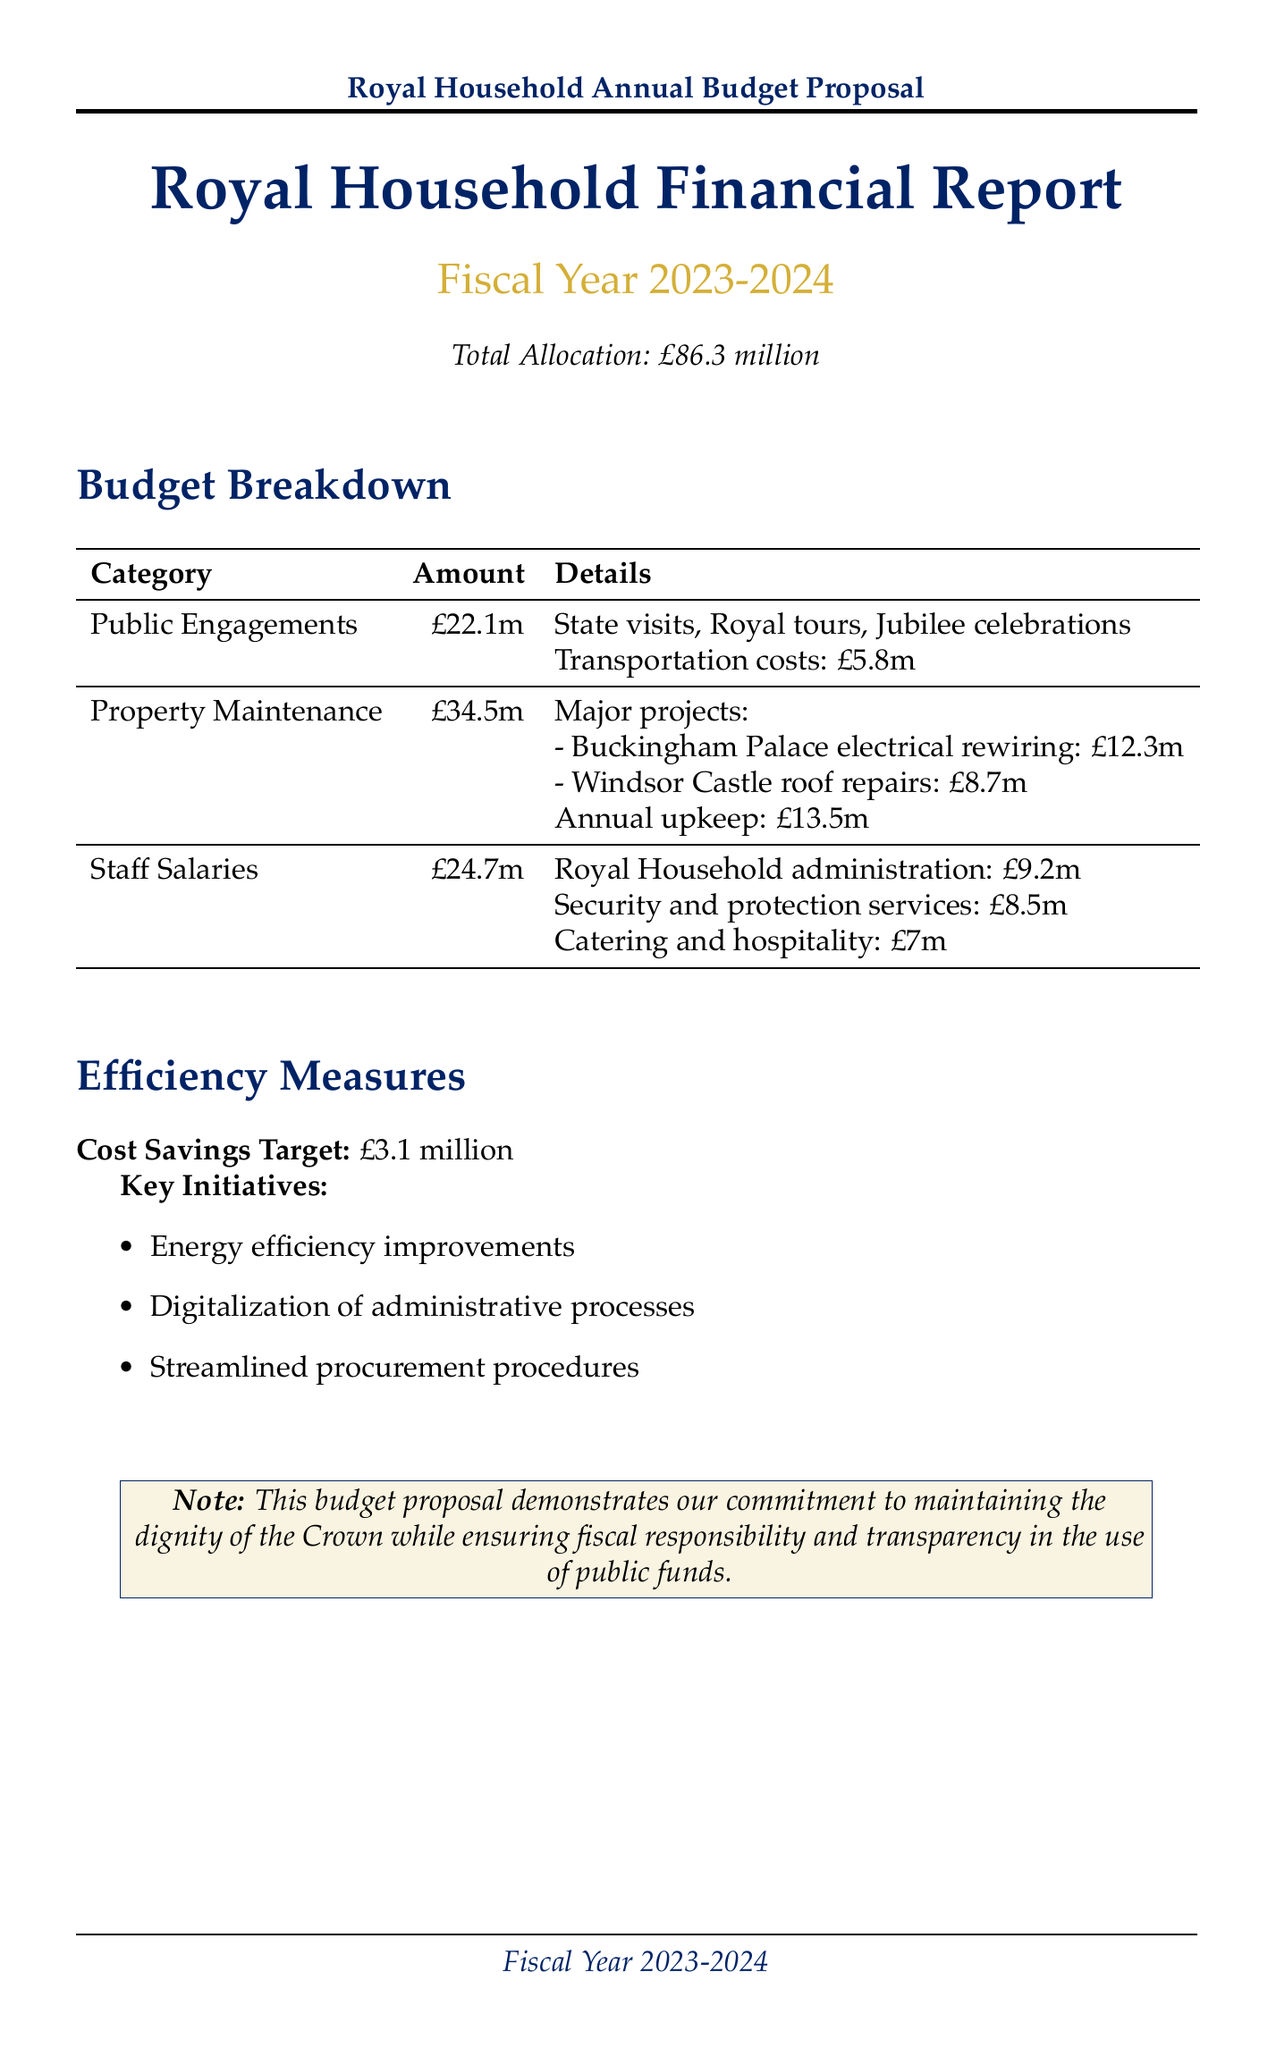What is the total allocation for the fiscal year? The total allocation for the fiscal year is clearly stated in the document.
Answer: £86.3 million How much is allocated for public engagements? The public engagements section specifies the total allocation amount.
Answer: £22.1 million What are the major projects included in property maintenance? The document lists two major projects under property maintenance with their corresponding costs.
Answer: Buckingham Palace electrical rewiring, Windsor Castle roof repairs What is the total allocation for staff salaries? The staff salaries section provides the total allocation amount for that category.
Answer: £24.7 million What is the cost savings target for the efficiency measures? The document mentions a specific cost savings target under efficiency measures.
Answer: £3.1 million How much is allocated for Windsor Castle roof repairs? Windsor Castle roof repairs is detailed under property maintenance with its respective cost.
Answer: £8.7 million How much does the Royal Household administration receive? The document indicates the allocation for each department within staff salaries.
Answer: £9.2 million What are some key events included in the public engagements allocation? The public engagements section lists key events to clarify how funds will be used.
Answer: State visits, Royal tours, Jubilee celebrations What initiatives are part of the efficiency measures? The efficiency measures section outlines specific initiatives aimed at achieving cost savings.
Answer: Energy efficiency improvements, Digitalization of administrative processes, Streamlined procurement procedures 